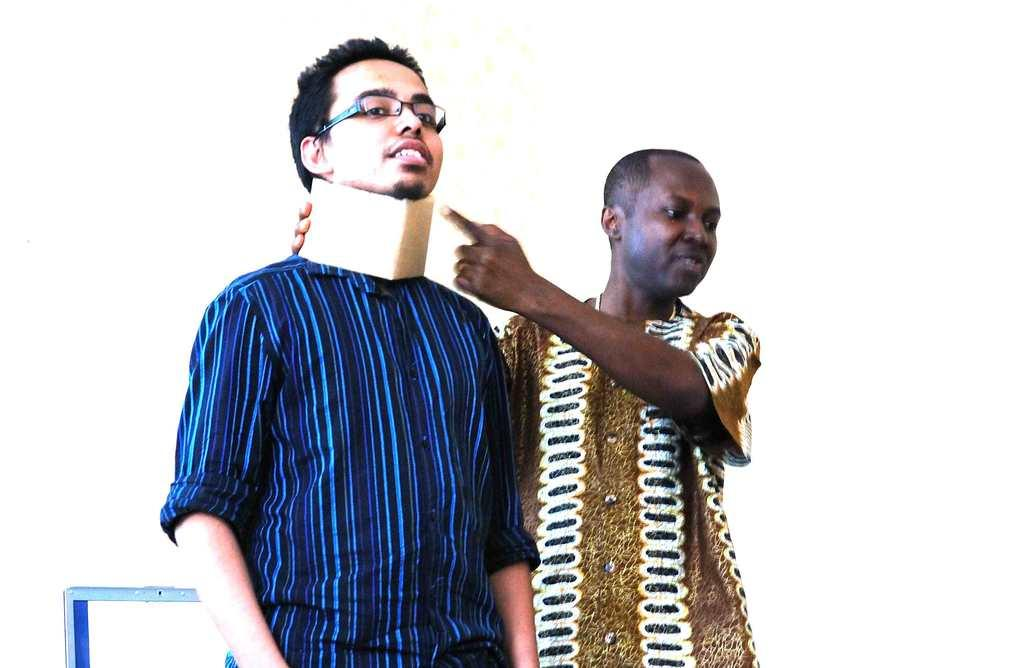How many people are in the image? There are two men standing in the image. What is the man wearing around his neck? One of the men is wearing a neck pad. What type of eyewear is the man wearing? The man is wearing spectacles. What color is the background of the image? The background of the image is white. What material is the object at the bottom of the image made of? The object at the bottom of the image is made of metal. What type of window can be seen in the image? There is no window present in the image. What type of play is the minister attending in the image? There is no minister or play present in the image. 